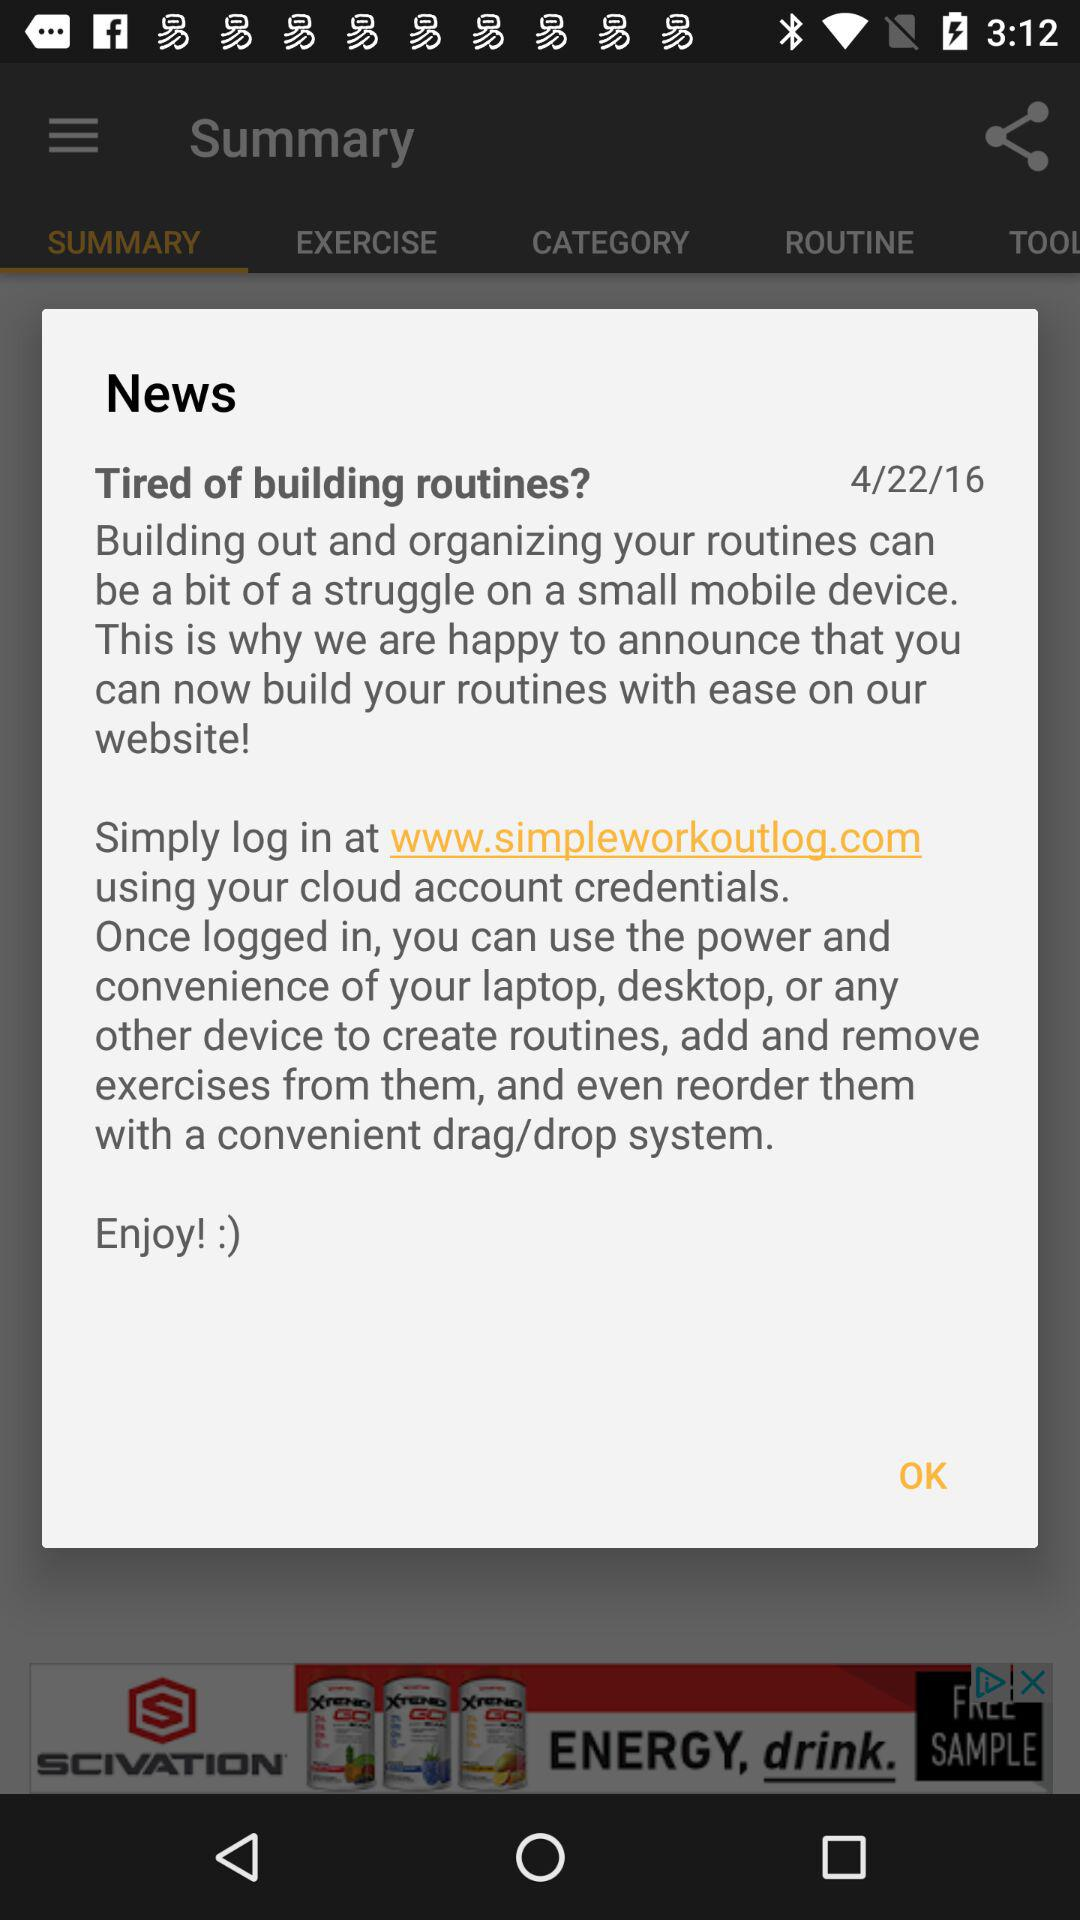When was the news posted? The news was posted on April 22, 2016. 